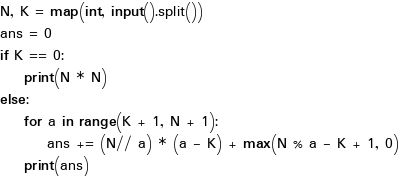Convert code to text. <code><loc_0><loc_0><loc_500><loc_500><_Python_>N, K = map(int, input().split())
ans = 0
if K == 0:
    print(N * N)
else:
    for a in range(K + 1, N + 1):
        ans += (N// a) * (a - K) + max(N % a - K + 1, 0)
    print(ans)
</code> 